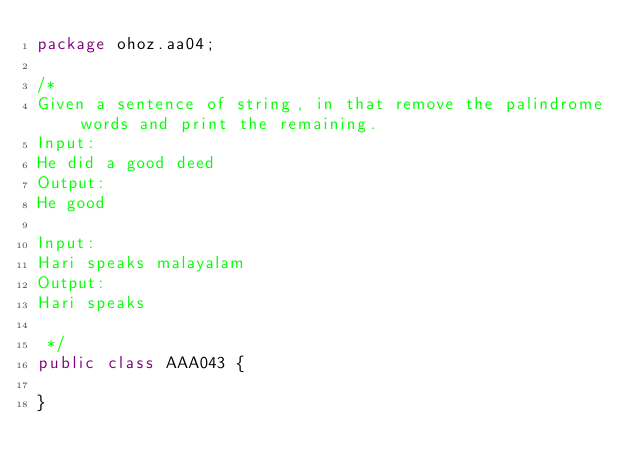Convert code to text. <code><loc_0><loc_0><loc_500><loc_500><_Java_>package ohoz.aa04;

/*
Given a sentence of string, in that remove the palindrome words and print the remaining.
Input:
He did a good deed
Output:
He good

Input:
Hari speaks malayalam
Output:
Hari speaks

 */
public class AAA043 {

}
</code> 